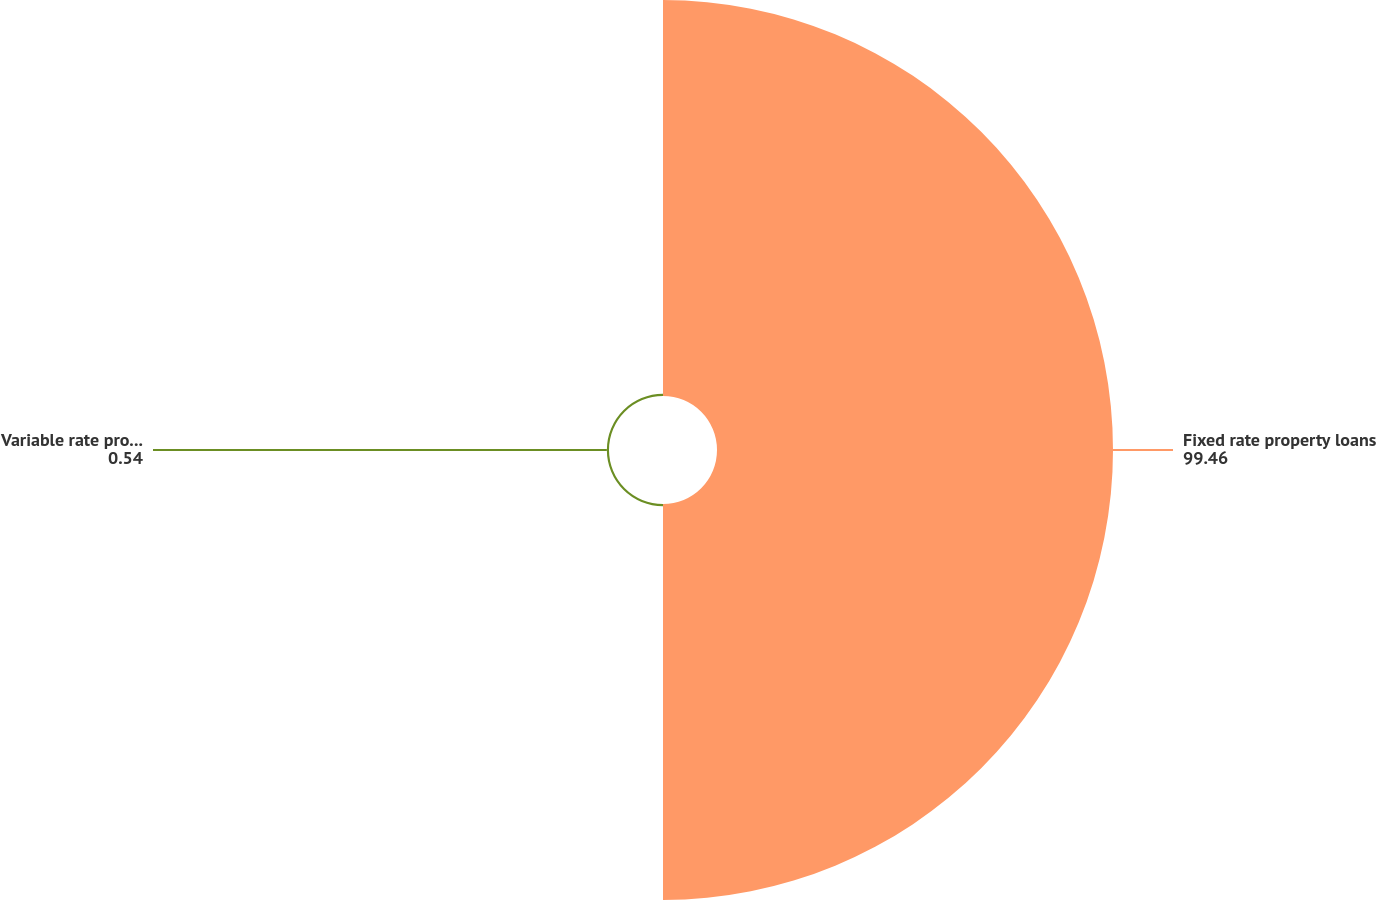Convert chart. <chart><loc_0><loc_0><loc_500><loc_500><pie_chart><fcel>Fixed rate property loans<fcel>Variable rate property loans<nl><fcel>99.46%<fcel>0.54%<nl></chart> 